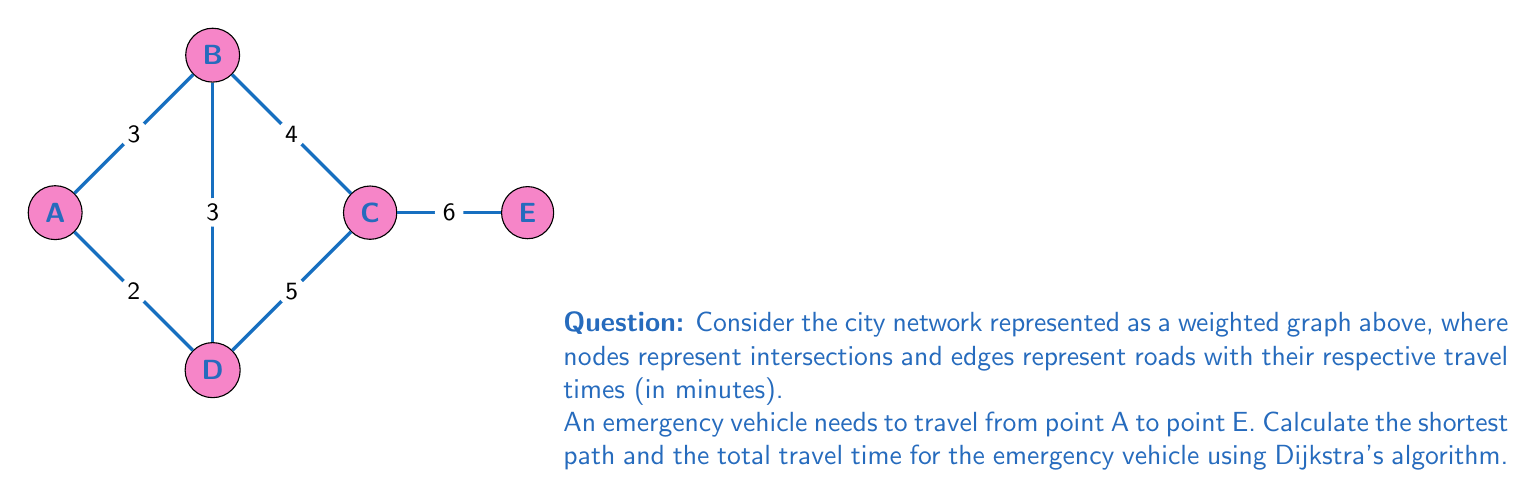Show me your answer to this math problem. To solve this problem, we'll use Dijkstra's algorithm to find the shortest path from A to E. Let's follow these steps:

1) Initialize:
   - Set distance to A as 0 and all other nodes as infinity.
   - Set all nodes as unvisited.
   - Set A as the current node.

2) For the current node, calculate the tentative distance to all unvisited neighbors:
   - A to B: 0 + 3 = 3
   - A to D: 0 + 2 = 2

3) Update distances if shorter path found and mark A as visited.

4) Select the unvisited node with the smallest tentative distance (D) as the new current node.

5) From D:
   - D to B: 2 + 3 = 5 (longer than existing, no update)
   - D to C: 2 + 5 = 7

6) Mark D as visited. Select B (distance 3) as the new current node.

7) From B:
   - B to C: 3 + 4 = 7 (same as existing, no update)

8) Mark B as visited. Select C (distance 7) as the new current node.

9) From C:
   - C to E: 7 + 6 = 13

10) Mark C as visited. E is the only unvisited node left.

The shortest path is A → D → C → E with a total distance of 13 minutes.

The path can be represented mathematically as:

$$P = \{v_1, v_2, ..., v_n\}$$

Where $P$ is the path, and $v_i$ are the vertices (nodes) in the order they are visited.

The total travel time $T$ is calculated as:

$$T = \sum_{i=1}^{n-1} w(v_i, v_{i+1})$$

Where $w(v_i, v_{i+1})$ is the weight (travel time) between consecutive vertices.
Answer: Path: A → D → C → E; Total time: 13 minutes 